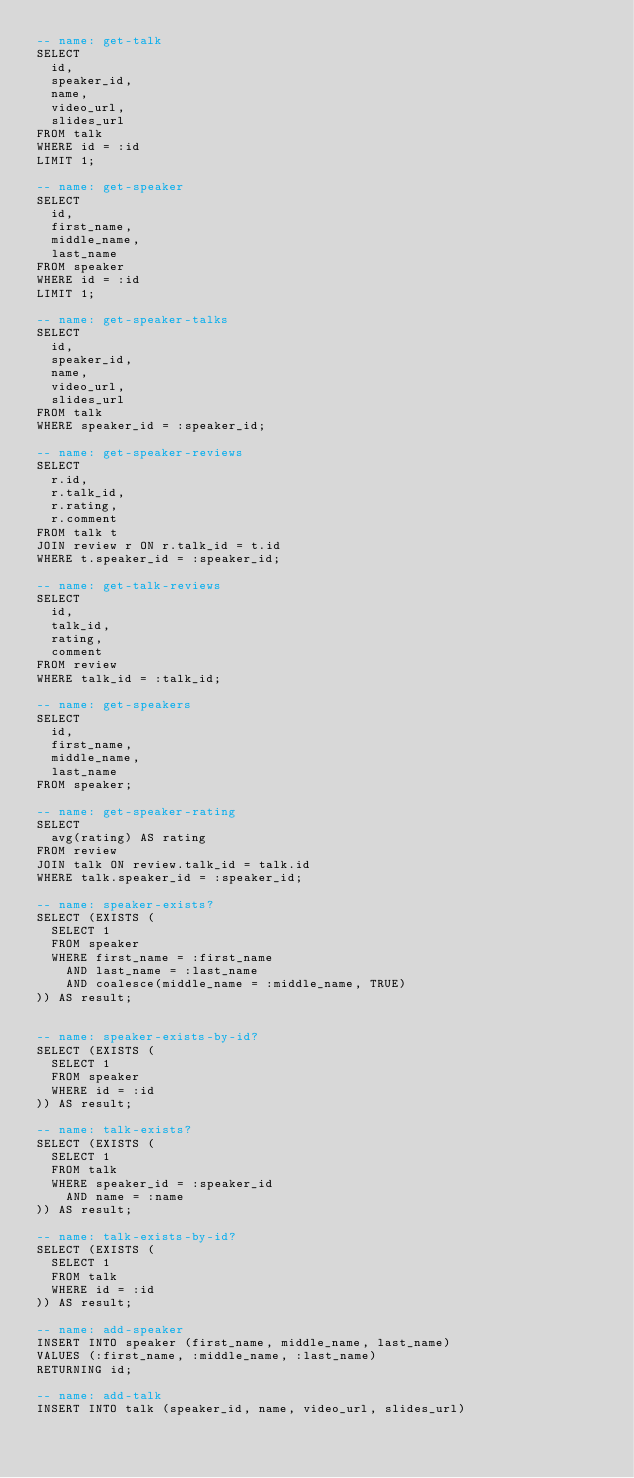<code> <loc_0><loc_0><loc_500><loc_500><_SQL_>-- name: get-talk
SELECT
  id,
  speaker_id,
  name,
  video_url,
  slides_url
FROM talk
WHERE id = :id
LIMIT 1;

-- name: get-speaker
SELECT
  id,
  first_name,
  middle_name,
  last_name
FROM speaker
WHERE id = :id
LIMIT 1;

-- name: get-speaker-talks
SELECT
  id,
  speaker_id,
  name,
  video_url,
  slides_url
FROM talk
WHERE speaker_id = :speaker_id;

-- name: get-speaker-reviews
SELECT
  r.id,
  r.talk_id,
  r.rating,
  r.comment
FROM talk t
JOIN review r ON r.talk_id = t.id
WHERE t.speaker_id = :speaker_id;

-- name: get-talk-reviews
SELECT
  id,
  talk_id,
  rating,
  comment
FROM review
WHERE talk_id = :talk_id;

-- name: get-speakers
SELECT
  id,
  first_name,
  middle_name,
  last_name
FROM speaker;

-- name: get-speaker-rating
SELECT
  avg(rating) AS rating
FROM review
JOIN talk ON review.talk_id = talk.id
WHERE talk.speaker_id = :speaker_id;

-- name: speaker-exists?
SELECT (EXISTS (
  SELECT 1
  FROM speaker
  WHERE first_name = :first_name
    AND last_name = :last_name
    AND coalesce(middle_name = :middle_name, TRUE)
)) AS result;


-- name: speaker-exists-by-id?
SELECT (EXISTS (
  SELECT 1
  FROM speaker
  WHERE id = :id
)) AS result;

-- name: talk-exists?
SELECT (EXISTS (
  SELECT 1
  FROM talk
  WHERE speaker_id = :speaker_id
    AND name = :name
)) AS result;

-- name: talk-exists-by-id?
SELECT (EXISTS (
  SELECT 1
  FROM talk
  WHERE id = :id
)) AS result;

-- name: add-speaker
INSERT INTO speaker (first_name, middle_name, last_name)
VALUES (:first_name, :middle_name, :last_name)
RETURNING id;

-- name: add-talk
INSERT INTO talk (speaker_id, name, video_url, slides_url)</code> 